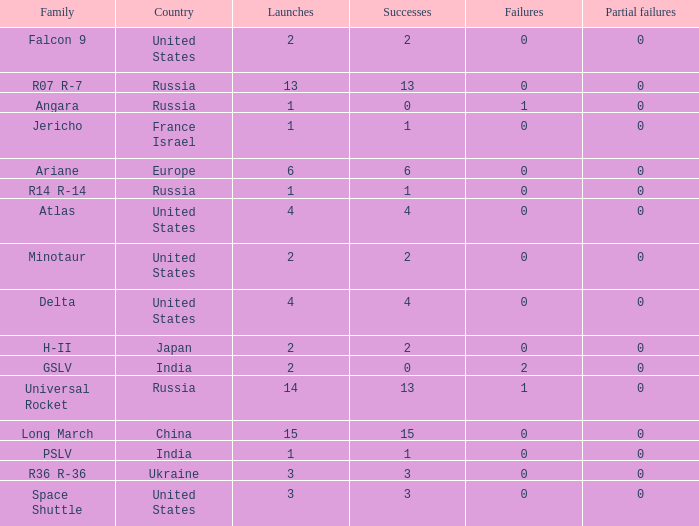What is the number of failure for the country of Russia, and a Family of r14 r-14, and a Partial failures smaller than 0? 0.0. 